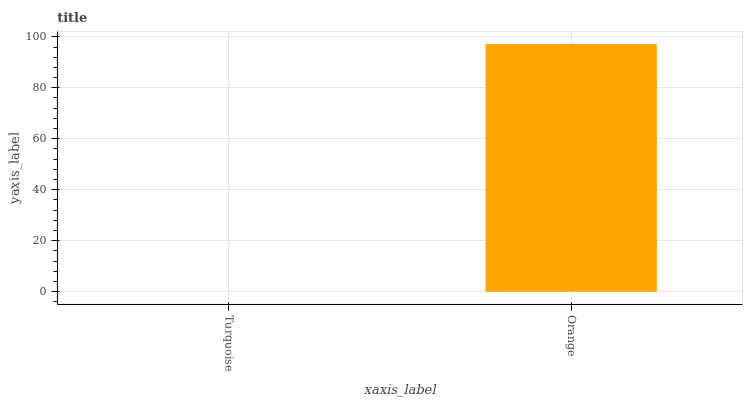Is Turquoise the minimum?
Answer yes or no. Yes. Is Orange the maximum?
Answer yes or no. Yes. Is Orange the minimum?
Answer yes or no. No. Is Orange greater than Turquoise?
Answer yes or no. Yes. Is Turquoise less than Orange?
Answer yes or no. Yes. Is Turquoise greater than Orange?
Answer yes or no. No. Is Orange less than Turquoise?
Answer yes or no. No. Is Orange the high median?
Answer yes or no. Yes. Is Turquoise the low median?
Answer yes or no. Yes. Is Turquoise the high median?
Answer yes or no. No. Is Orange the low median?
Answer yes or no. No. 